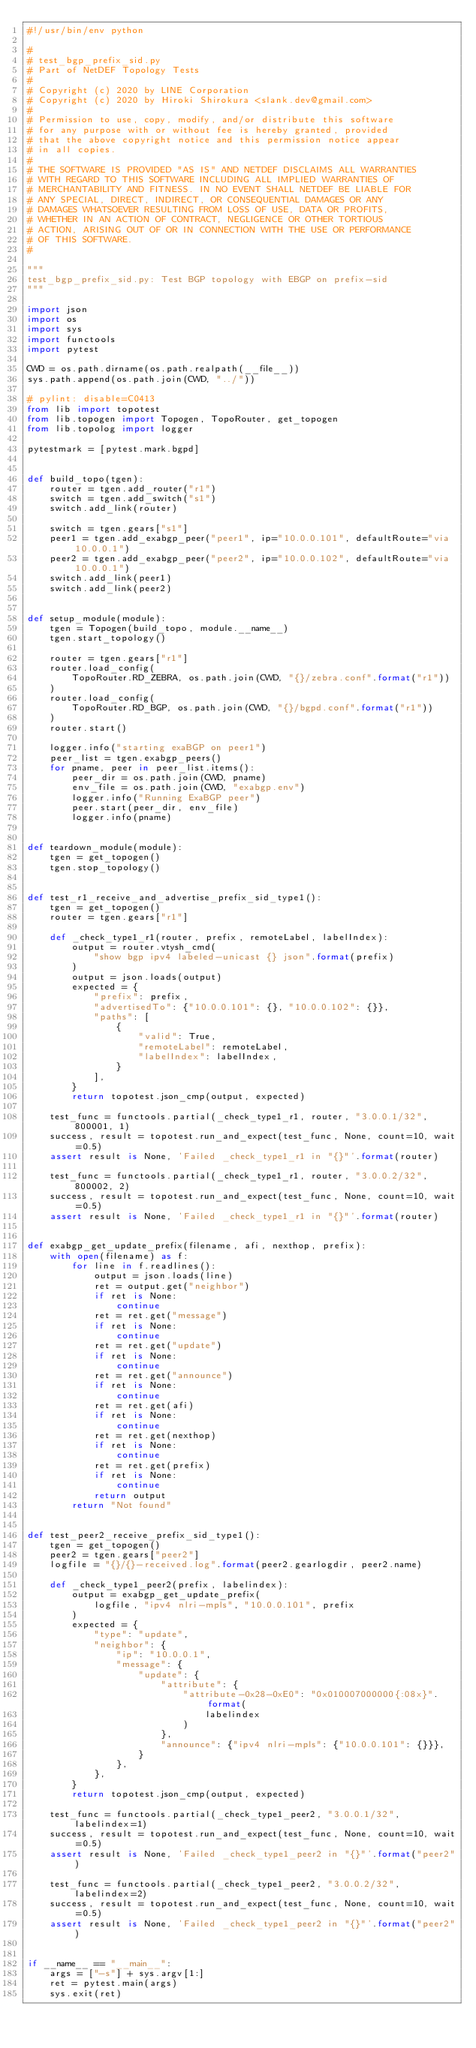Convert code to text. <code><loc_0><loc_0><loc_500><loc_500><_Python_>#!/usr/bin/env python

#
# test_bgp_prefix_sid.py
# Part of NetDEF Topology Tests
#
# Copyright (c) 2020 by LINE Corporation
# Copyright (c) 2020 by Hiroki Shirokura <slank.dev@gmail.com>
#
# Permission to use, copy, modify, and/or distribute this software
# for any purpose with or without fee is hereby granted, provided
# that the above copyright notice and this permission notice appear
# in all copies.
#
# THE SOFTWARE IS PROVIDED "AS IS" AND NETDEF DISCLAIMS ALL WARRANTIES
# WITH REGARD TO THIS SOFTWARE INCLUDING ALL IMPLIED WARRANTIES OF
# MERCHANTABILITY AND FITNESS. IN NO EVENT SHALL NETDEF BE LIABLE FOR
# ANY SPECIAL, DIRECT, INDIRECT, OR CONSEQUENTIAL DAMAGES OR ANY
# DAMAGES WHATSOEVER RESULTING FROM LOSS OF USE, DATA OR PROFITS,
# WHETHER IN AN ACTION OF CONTRACT, NEGLIGENCE OR OTHER TORTIOUS
# ACTION, ARISING OUT OF OR IN CONNECTION WITH THE USE OR PERFORMANCE
# OF THIS SOFTWARE.
#

"""
test_bgp_prefix_sid.py: Test BGP topology with EBGP on prefix-sid
"""

import json
import os
import sys
import functools
import pytest

CWD = os.path.dirname(os.path.realpath(__file__))
sys.path.append(os.path.join(CWD, "../"))

# pylint: disable=C0413
from lib import topotest
from lib.topogen import Topogen, TopoRouter, get_topogen
from lib.topolog import logger

pytestmark = [pytest.mark.bgpd]


def build_topo(tgen):
    router = tgen.add_router("r1")
    switch = tgen.add_switch("s1")
    switch.add_link(router)

    switch = tgen.gears["s1"]
    peer1 = tgen.add_exabgp_peer("peer1", ip="10.0.0.101", defaultRoute="via 10.0.0.1")
    peer2 = tgen.add_exabgp_peer("peer2", ip="10.0.0.102", defaultRoute="via 10.0.0.1")
    switch.add_link(peer1)
    switch.add_link(peer2)


def setup_module(module):
    tgen = Topogen(build_topo, module.__name__)
    tgen.start_topology()

    router = tgen.gears["r1"]
    router.load_config(
        TopoRouter.RD_ZEBRA, os.path.join(CWD, "{}/zebra.conf".format("r1"))
    )
    router.load_config(
        TopoRouter.RD_BGP, os.path.join(CWD, "{}/bgpd.conf".format("r1"))
    )
    router.start()

    logger.info("starting exaBGP on peer1")
    peer_list = tgen.exabgp_peers()
    for pname, peer in peer_list.items():
        peer_dir = os.path.join(CWD, pname)
        env_file = os.path.join(CWD, "exabgp.env")
        logger.info("Running ExaBGP peer")
        peer.start(peer_dir, env_file)
        logger.info(pname)


def teardown_module(module):
    tgen = get_topogen()
    tgen.stop_topology()


def test_r1_receive_and_advertise_prefix_sid_type1():
    tgen = get_topogen()
    router = tgen.gears["r1"]

    def _check_type1_r1(router, prefix, remoteLabel, labelIndex):
        output = router.vtysh_cmd(
            "show bgp ipv4 labeled-unicast {} json".format(prefix)
        )
        output = json.loads(output)
        expected = {
            "prefix": prefix,
            "advertisedTo": {"10.0.0.101": {}, "10.0.0.102": {}},
            "paths": [
                {
                    "valid": True,
                    "remoteLabel": remoteLabel,
                    "labelIndex": labelIndex,
                }
            ],
        }
        return topotest.json_cmp(output, expected)

    test_func = functools.partial(_check_type1_r1, router, "3.0.0.1/32", 800001, 1)
    success, result = topotest.run_and_expect(test_func, None, count=10, wait=0.5)
    assert result is None, 'Failed _check_type1_r1 in "{}"'.format(router)

    test_func = functools.partial(_check_type1_r1, router, "3.0.0.2/32", 800002, 2)
    success, result = topotest.run_and_expect(test_func, None, count=10, wait=0.5)
    assert result is None, 'Failed _check_type1_r1 in "{}"'.format(router)


def exabgp_get_update_prefix(filename, afi, nexthop, prefix):
    with open(filename) as f:
        for line in f.readlines():
            output = json.loads(line)
            ret = output.get("neighbor")
            if ret is None:
                continue
            ret = ret.get("message")
            if ret is None:
                continue
            ret = ret.get("update")
            if ret is None:
                continue
            ret = ret.get("announce")
            if ret is None:
                continue
            ret = ret.get(afi)
            if ret is None:
                continue
            ret = ret.get(nexthop)
            if ret is None:
                continue
            ret = ret.get(prefix)
            if ret is None:
                continue
            return output
        return "Not found"


def test_peer2_receive_prefix_sid_type1():
    tgen = get_topogen()
    peer2 = tgen.gears["peer2"]
    logfile = "{}/{}-received.log".format(peer2.gearlogdir, peer2.name)

    def _check_type1_peer2(prefix, labelindex):
        output = exabgp_get_update_prefix(
            logfile, "ipv4 nlri-mpls", "10.0.0.101", prefix
        )
        expected = {
            "type": "update",
            "neighbor": {
                "ip": "10.0.0.1",
                "message": {
                    "update": {
                        "attribute": {
                            "attribute-0x28-0xE0": "0x010007000000{:08x}".format(
                                labelindex
                            )
                        },
                        "announce": {"ipv4 nlri-mpls": {"10.0.0.101": {}}},
                    }
                },
            },
        }
        return topotest.json_cmp(output, expected)

    test_func = functools.partial(_check_type1_peer2, "3.0.0.1/32", labelindex=1)
    success, result = topotest.run_and_expect(test_func, None, count=10, wait=0.5)
    assert result is None, 'Failed _check_type1_peer2 in "{}"'.format("peer2")

    test_func = functools.partial(_check_type1_peer2, "3.0.0.2/32", labelindex=2)
    success, result = topotest.run_and_expect(test_func, None, count=10, wait=0.5)
    assert result is None, 'Failed _check_type1_peer2 in "{}"'.format("peer2")


if __name__ == "__main__":
    args = ["-s"] + sys.argv[1:]
    ret = pytest.main(args)
    sys.exit(ret)
</code> 